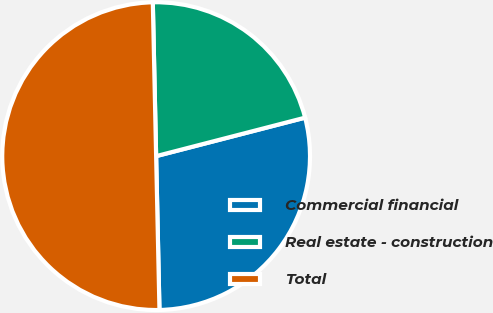Convert chart to OTSL. <chart><loc_0><loc_0><loc_500><loc_500><pie_chart><fcel>Commercial financial<fcel>Real estate - construction<fcel>Total<nl><fcel>28.68%<fcel>21.32%<fcel>50.0%<nl></chart> 